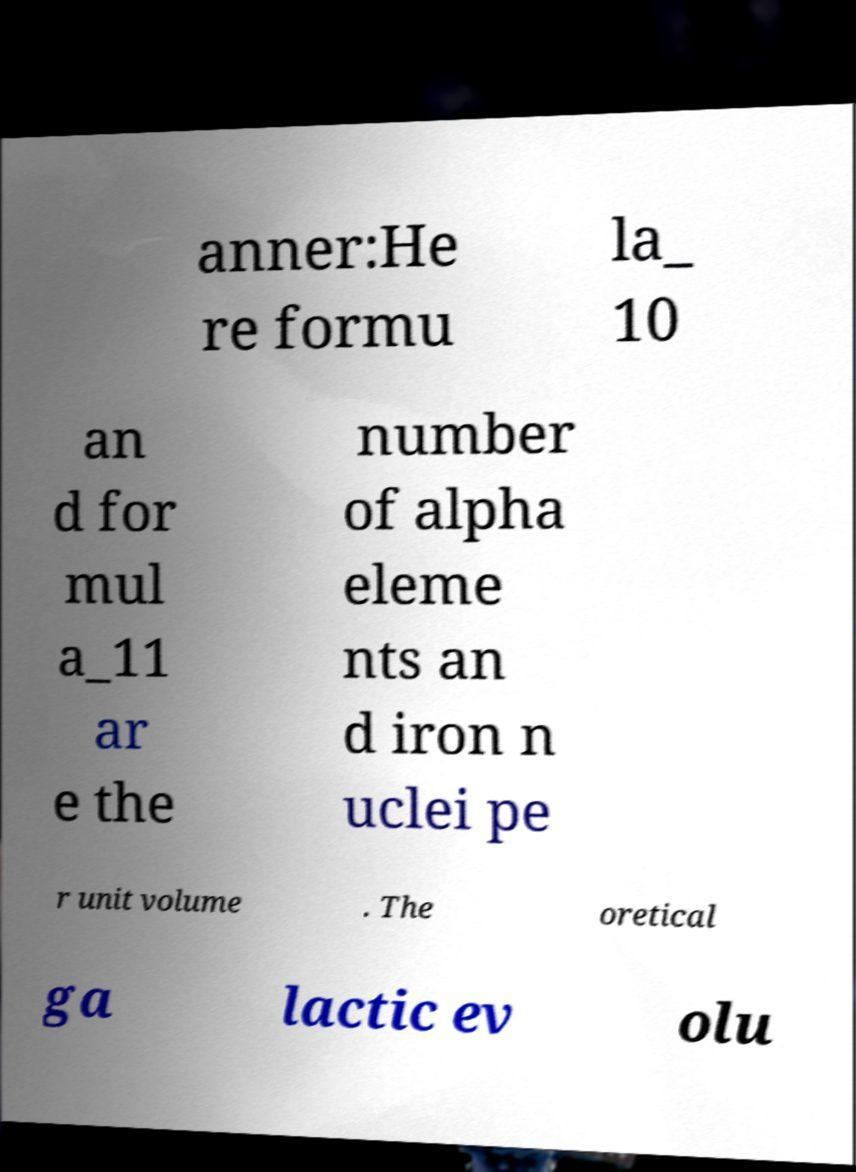Can you accurately transcribe the text from the provided image for me? anner:He re formu la_ 10 an d for mul a_11 ar e the number of alpha eleme nts an d iron n uclei pe r unit volume . The oretical ga lactic ev olu 